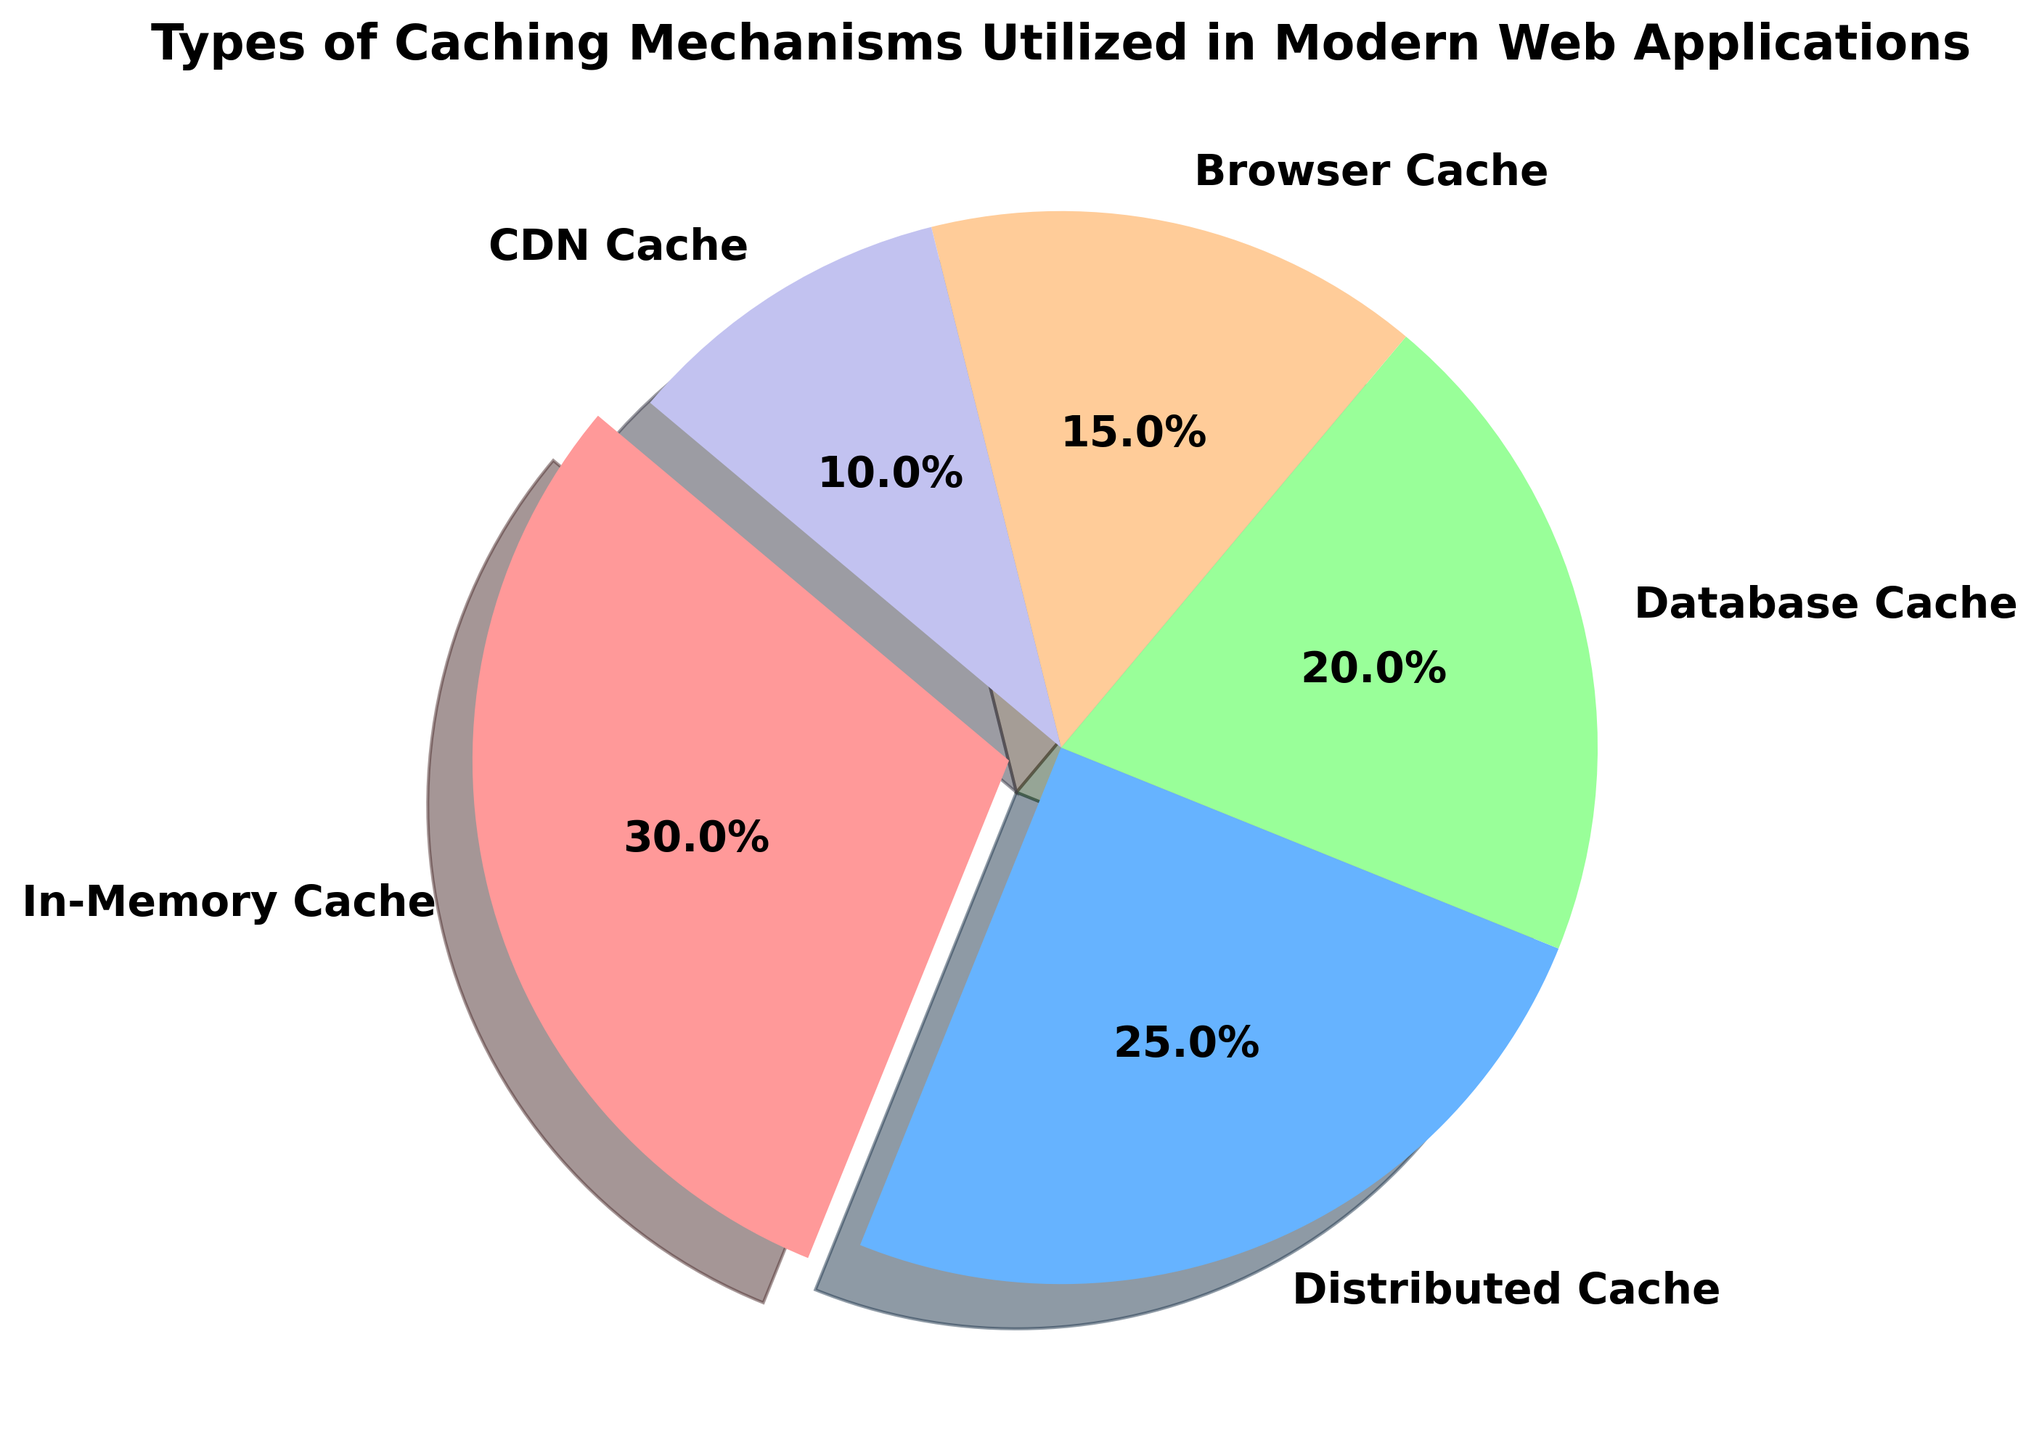Which type of caching mechanism has the highest usage in modern web applications? The pie chart shows that the "In-Memory Cache" segment is the largest, making it the caching mechanism with the highest usage.
Answer: In-Memory Cache How much larger is the percentage of In-Memory Cache compared to CDN Cache? In-Memory Cache has a percentage of 30%, while CDN Cache has 10%. The difference is calculated as 30% - 10% = 20%.
Answer: 20% What percentage of caching mechanisms is distributed cache? The "Distributed Cache" segment is labelled with a percentage of 25% in the pie chart.
Answer: 25% Which two caching mechanisms combined account for 45% of the total caching mechanisms? Adding the percentages, "Database Cache" (20%) and "Browser Cache" (15%) together is 20% + 15% = 35%. But "Distributed Cache" (25%) and "Browser Cache" (15%) together is 25% + 15% = 45%.
Answer: Distributed Cache and Browser Cache Which caching mechanism is represented by the smallest segment and what is its percentage? The smallest segment in the pie chart corresponds to "CDN Cache," which has 10%.
Answer: CDN Cache, 10% How much more frequently is Database Cache used compared to CDN Cache? Database Cache is at 20%, while CDN Cache is at 10%. The difference is 20% - 10% = 10%.
Answer: 10% If we combine the percentages of Browser Cache and CDN Cache, what fraction of the pie chart do they represent? Summing the percentages, Browser Cache (15%) and CDN Cache (10%) together make 15% + 10% = 25%.
Answer: 1/4 Which caching mechanism is represented by the exploded slice, and what is its significance? The exploded slice in the pie chart represents "In-Memory Cache." Exploding a slice typically emphasizes its importance or higher usage compared to others.
Answer: In-Memory Cache, emphasized What is the sum of the percentages of Database Cache and Browser Cache? Adding the percentages of Database Cache (20%) and Browser Cache (15%) gives 20% + 15% = 35%.
Answer: 35% Comparing In-Memory Cache and Distributed Cache, which is more prevalent and by what percentage? In-Memory Cache is 30%, and Distributed Cache is 25%. The difference is 30% - 25% = 5%.
Answer: In-Memory Cache, 5% 